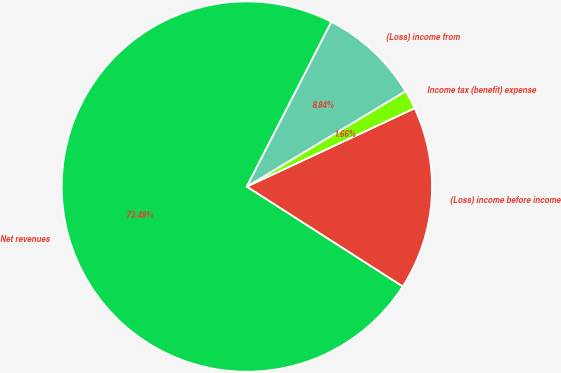Convert chart. <chart><loc_0><loc_0><loc_500><loc_500><pie_chart><fcel>Net revenues<fcel>(Loss) income before income<fcel>Income tax (benefit) expense<fcel>(Loss) income from<nl><fcel>73.48%<fcel>16.02%<fcel>1.66%<fcel>8.84%<nl></chart> 